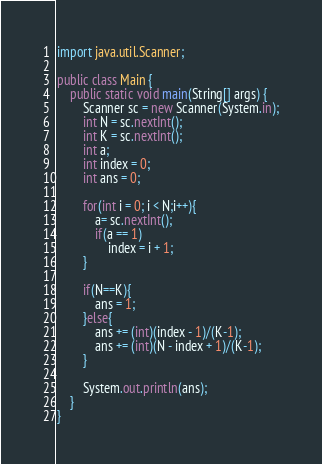Convert code to text. <code><loc_0><loc_0><loc_500><loc_500><_Java_>import java.util.Scanner;

public class Main {
	public static void main(String[] args) {
		Scanner sc = new Scanner(System.in);
		int N = sc.nextInt();
		int K = sc.nextInt();
		int a;
		int index = 0;
		int ans = 0;

		for(int i = 0; i < N;i++){
			a= sc.nextInt();
			if(a == 1)
				index = i + 1;
		}

		if(N==K){
			ans = 1;
		}else{
			ans += (int)(index - 1)/(K-1);
			ans += (int)(N - index + 1)/(K-1);
		}

		System.out.println(ans);
	}
}
</code> 